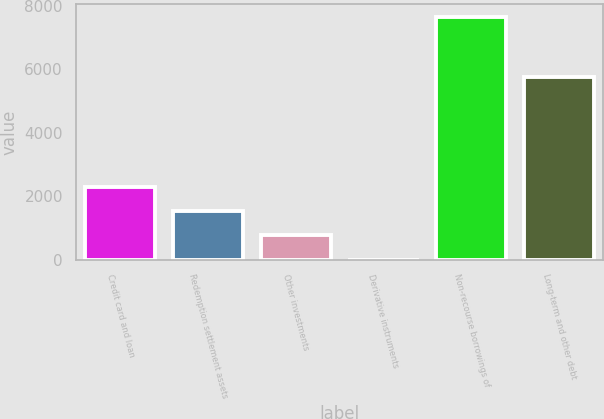Convert chart to OTSL. <chart><loc_0><loc_0><loc_500><loc_500><bar_chart><fcel>Credit card and loan<fcel>Redemption settlement assets<fcel>Other investments<fcel>Derivative instruments<fcel>Non-recourse borrowings of<fcel>Long-term and other debt<nl><fcel>2298.17<fcel>1533.38<fcel>768.59<fcel>3.8<fcel>7651.7<fcel>5737.9<nl></chart> 